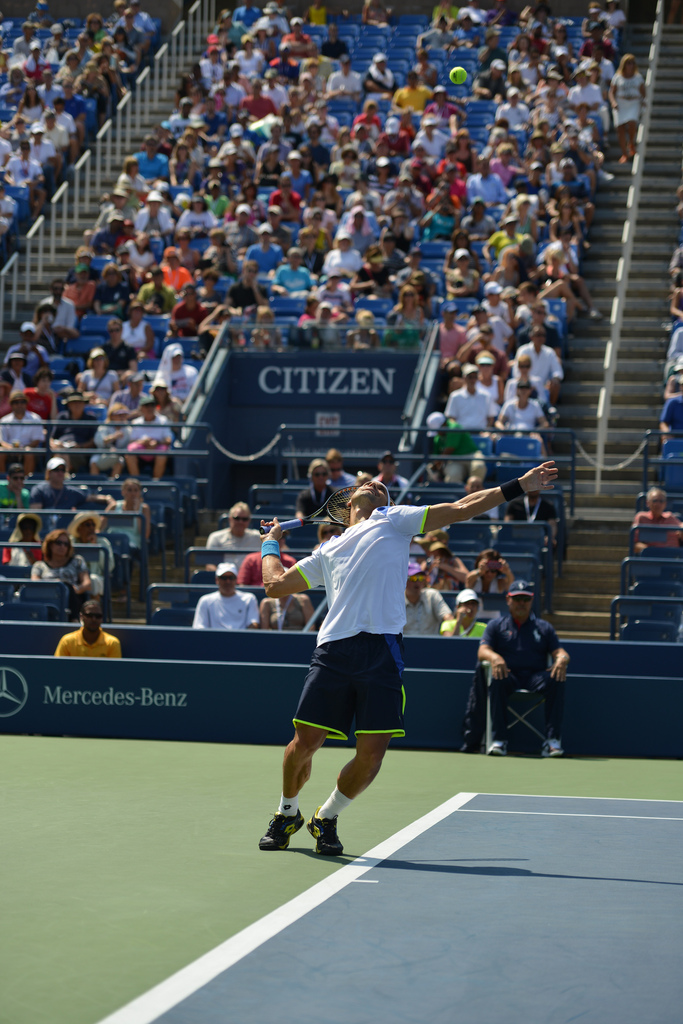Describe the action that the player is performing in the image. The player, wearing a white shirt and blue shorts, is in the middle of serving the tennis ball during a match, executing a powerful overhead serve to his opponent. What is the crowd's reaction in the background? The crowd is attentively watching the game, with many spectators focused on the trajectory of the ball and the players' movements. The stands are packed, indicating a high interest in this match. 